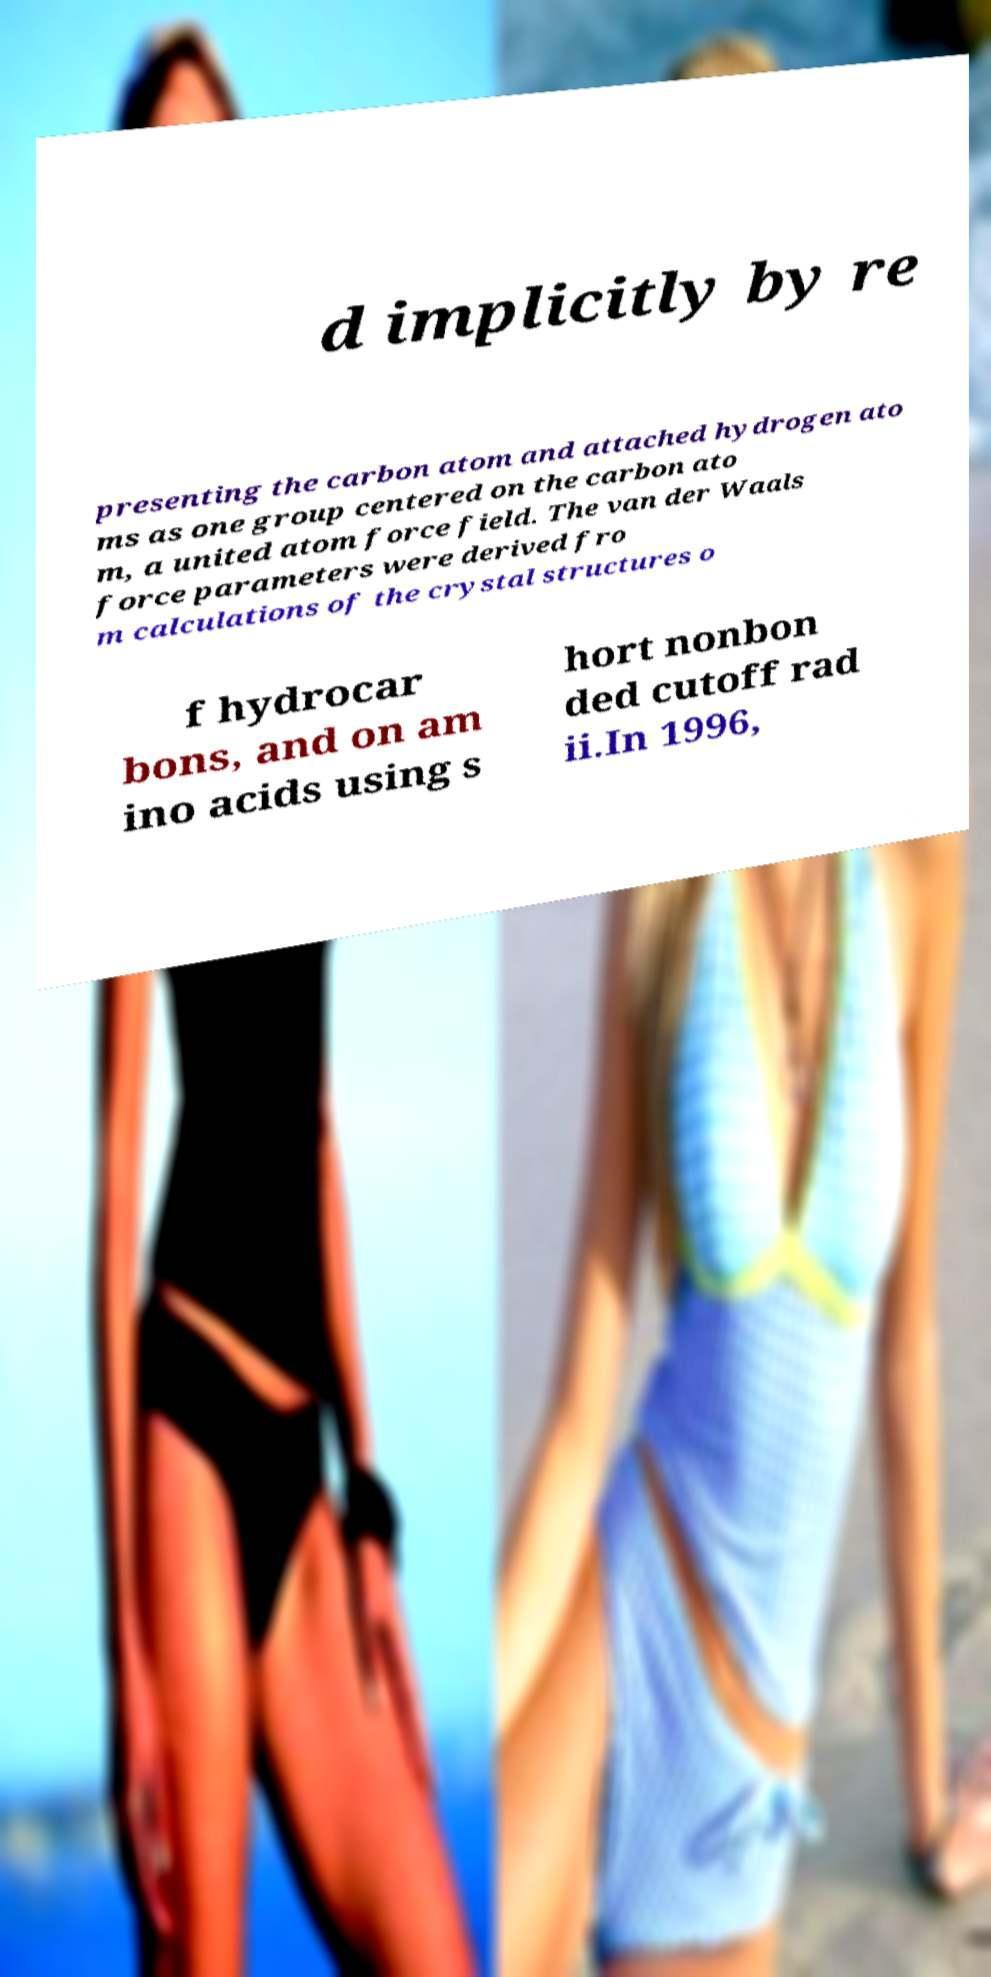I need the written content from this picture converted into text. Can you do that? d implicitly by re presenting the carbon atom and attached hydrogen ato ms as one group centered on the carbon ato m, a united atom force field. The van der Waals force parameters were derived fro m calculations of the crystal structures o f hydrocar bons, and on am ino acids using s hort nonbon ded cutoff rad ii.In 1996, 